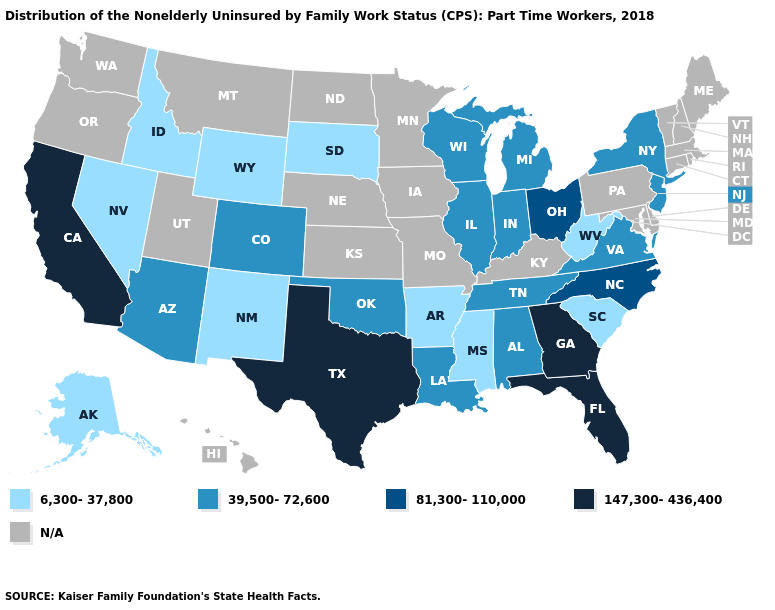What is the value of West Virginia?
Keep it brief. 6,300-37,800. What is the value of Rhode Island?
Short answer required. N/A. What is the highest value in the USA?
Write a very short answer. 147,300-436,400. Among the states that border Wisconsin , which have the highest value?
Write a very short answer. Illinois, Michigan. Which states have the lowest value in the USA?
Short answer required. Alaska, Arkansas, Idaho, Mississippi, Nevada, New Mexico, South Carolina, South Dakota, West Virginia, Wyoming. Is the legend a continuous bar?
Be succinct. No. Among the states that border West Virginia , which have the lowest value?
Keep it brief. Virginia. What is the value of Iowa?
Write a very short answer. N/A. Among the states that border Massachusetts , which have the highest value?
Answer briefly. New York. Which states have the lowest value in the USA?
Answer briefly. Alaska, Arkansas, Idaho, Mississippi, Nevada, New Mexico, South Carolina, South Dakota, West Virginia, Wyoming. What is the value of Massachusetts?
Be succinct. N/A. Name the states that have a value in the range 147,300-436,400?
Be succinct. California, Florida, Georgia, Texas. Name the states that have a value in the range 147,300-436,400?
Short answer required. California, Florida, Georgia, Texas. Which states hav the highest value in the South?
Be succinct. Florida, Georgia, Texas. 